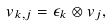<formula> <loc_0><loc_0><loc_500><loc_500>v _ { k , j } = \epsilon _ { k } \otimes v _ { j } ,</formula> 